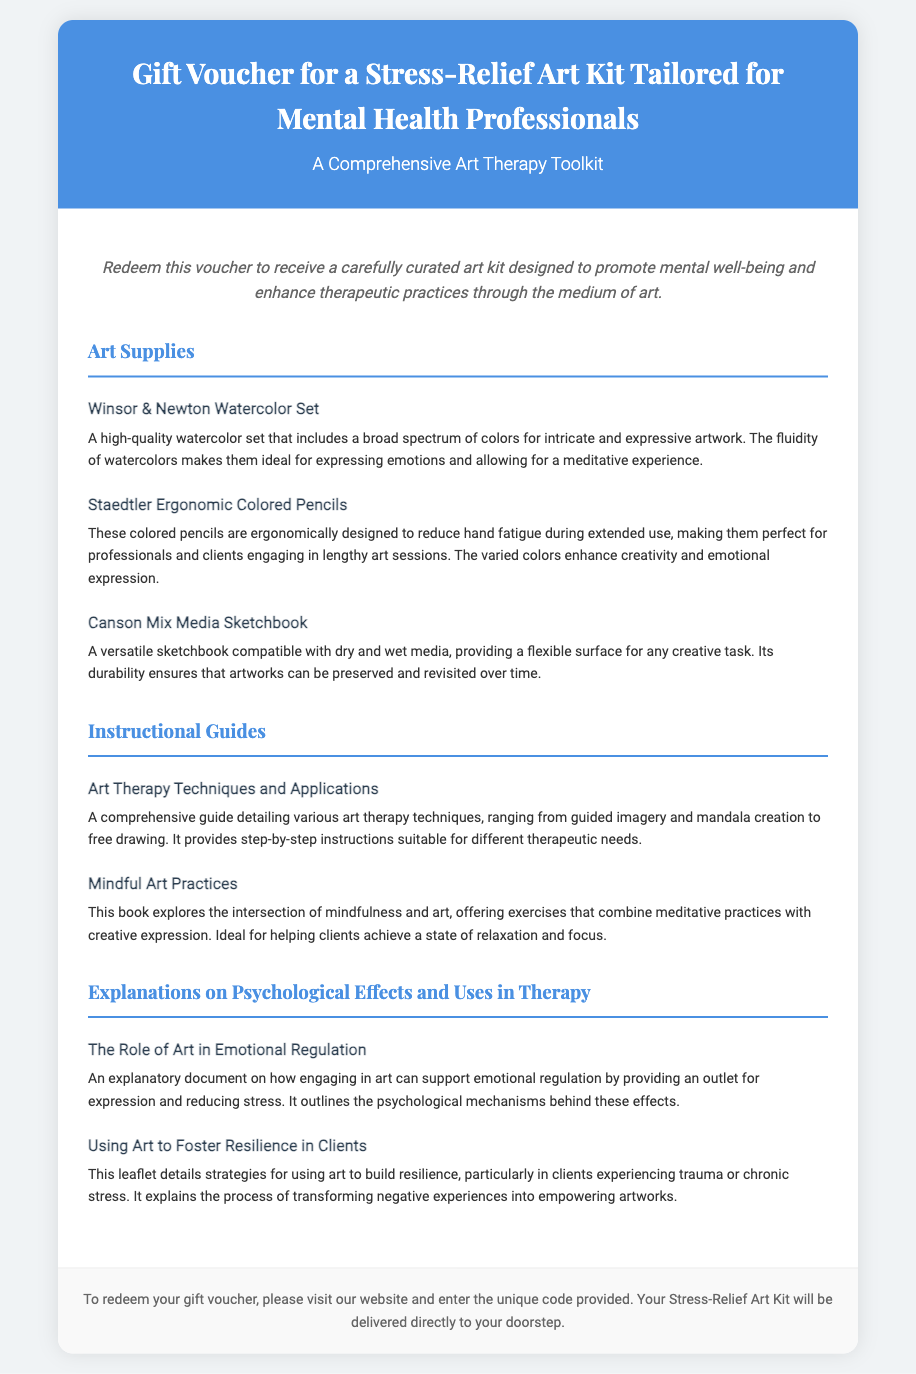What is the title of the voucher? The title of the voucher is prominently displayed at the top of the document, stating its purpose.
Answer: Gift Voucher for a Stress-Relief Art Kit Tailored for Mental Health Professionals How many artwork supplies are listed? The count of items under the "Art Supplies" category can be directly observed in the document.
Answer: 3 What is one of the instructional guides included? The document specifically names the instructional guides in the respective category, providing insight into the contents of the kit.
Answer: Art Therapy Techniques and Applications What psychological effect does engaging in art support? The document lists psychological effects in the therapy section, directly addressing benefits of art in emotional contexts.
Answer: Emotional regulation What is the final step to redeem the voucher? The last part of the document gives instructions on how to redeem the voucher, culminating in a call to action.
Answer: Visit our website Which colored pencils are mentioned in the kit? The document specifically names the colored pencil brand included in the art supplies section.
Answer: Staedtler Ergonomic Colored Pencils What is the main purpose of the art kit? The introductory section of the document elaborates on the kit’s intention for mental health professionals.
Answer: Promote mental well-being How many guides are part of the instructional materials? By counting the items listed under the "Instructional Guides" category in the document, the answer can be derived.
Answer: 2 